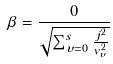<formula> <loc_0><loc_0><loc_500><loc_500>\beta = \frac { 0 } { \sqrt { \sum _ { \upsilon = 0 } ^ { s } \frac { j ^ { 2 } } { v _ { \upsilon } ^ { 2 } } } }</formula> 